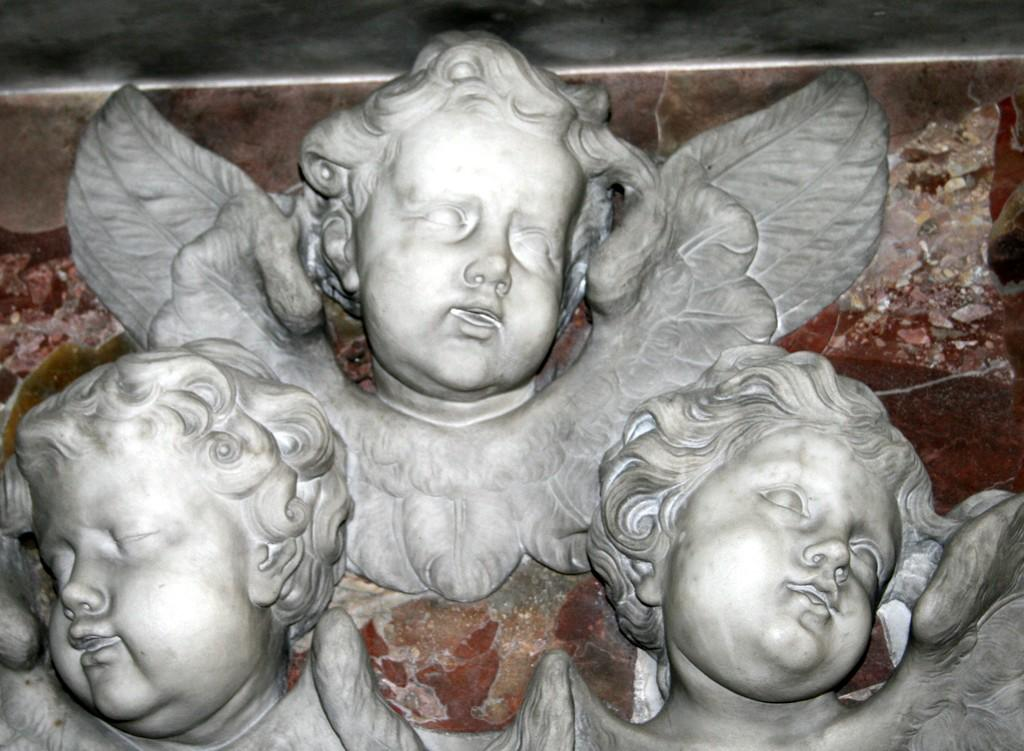How many faces are depicted in the image? There are three depictions of a person's face in the image. What feature do all the faces have in common? Each depiction has wings. Where are the faces located in the image? The depictions are on the surface of the image. What type of plantation can be seen in the image? There is no plantation present in the image. How many clovers are visible in the image? There are no clovers visible in the image. 